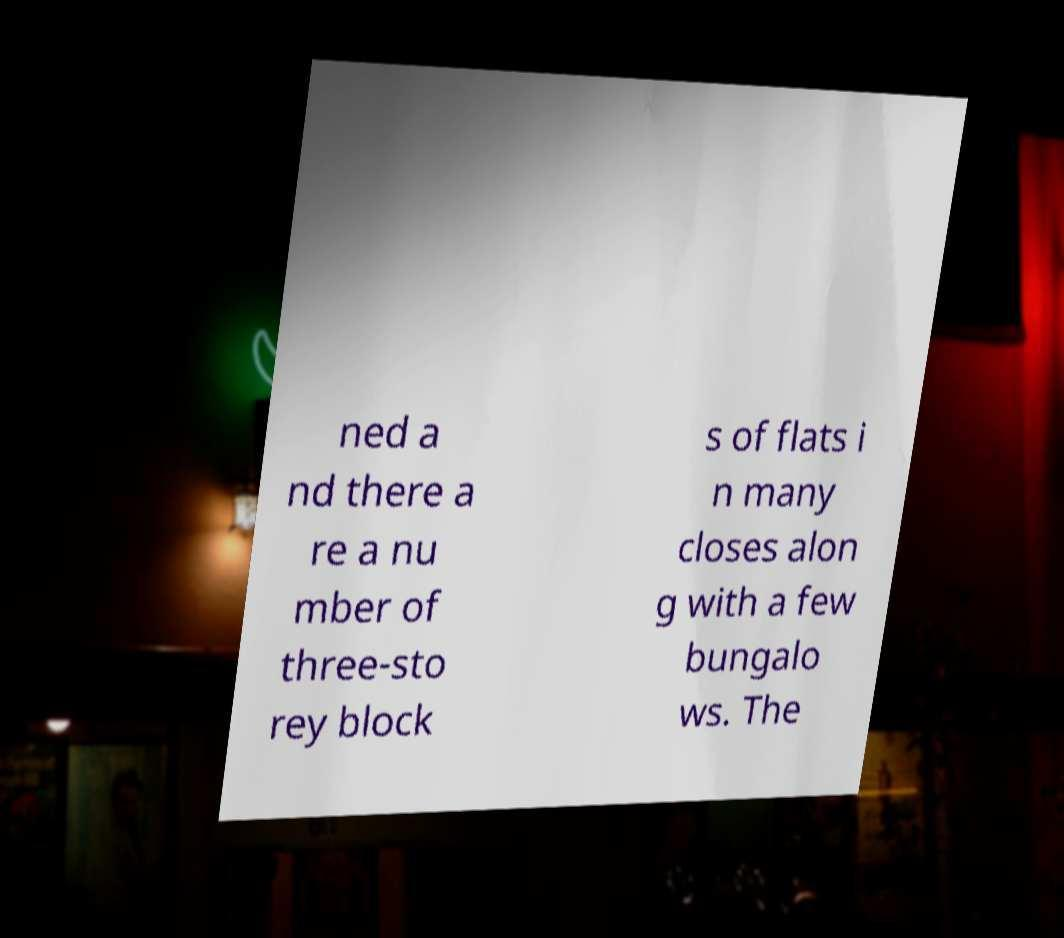What messages or text are displayed in this image? I need them in a readable, typed format. ned a nd there a re a nu mber of three-sto rey block s of flats i n many closes alon g with a few bungalo ws. The 